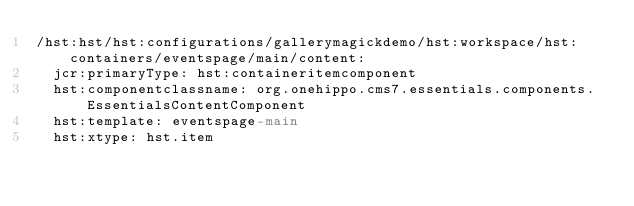Convert code to text. <code><loc_0><loc_0><loc_500><loc_500><_YAML_>/hst:hst/hst:configurations/gallerymagickdemo/hst:workspace/hst:containers/eventspage/main/content:
  jcr:primaryType: hst:containeritemcomponent
  hst:componentclassname: org.onehippo.cms7.essentials.components.EssentialsContentComponent
  hst:template: eventspage-main
  hst:xtype: hst.item
</code> 